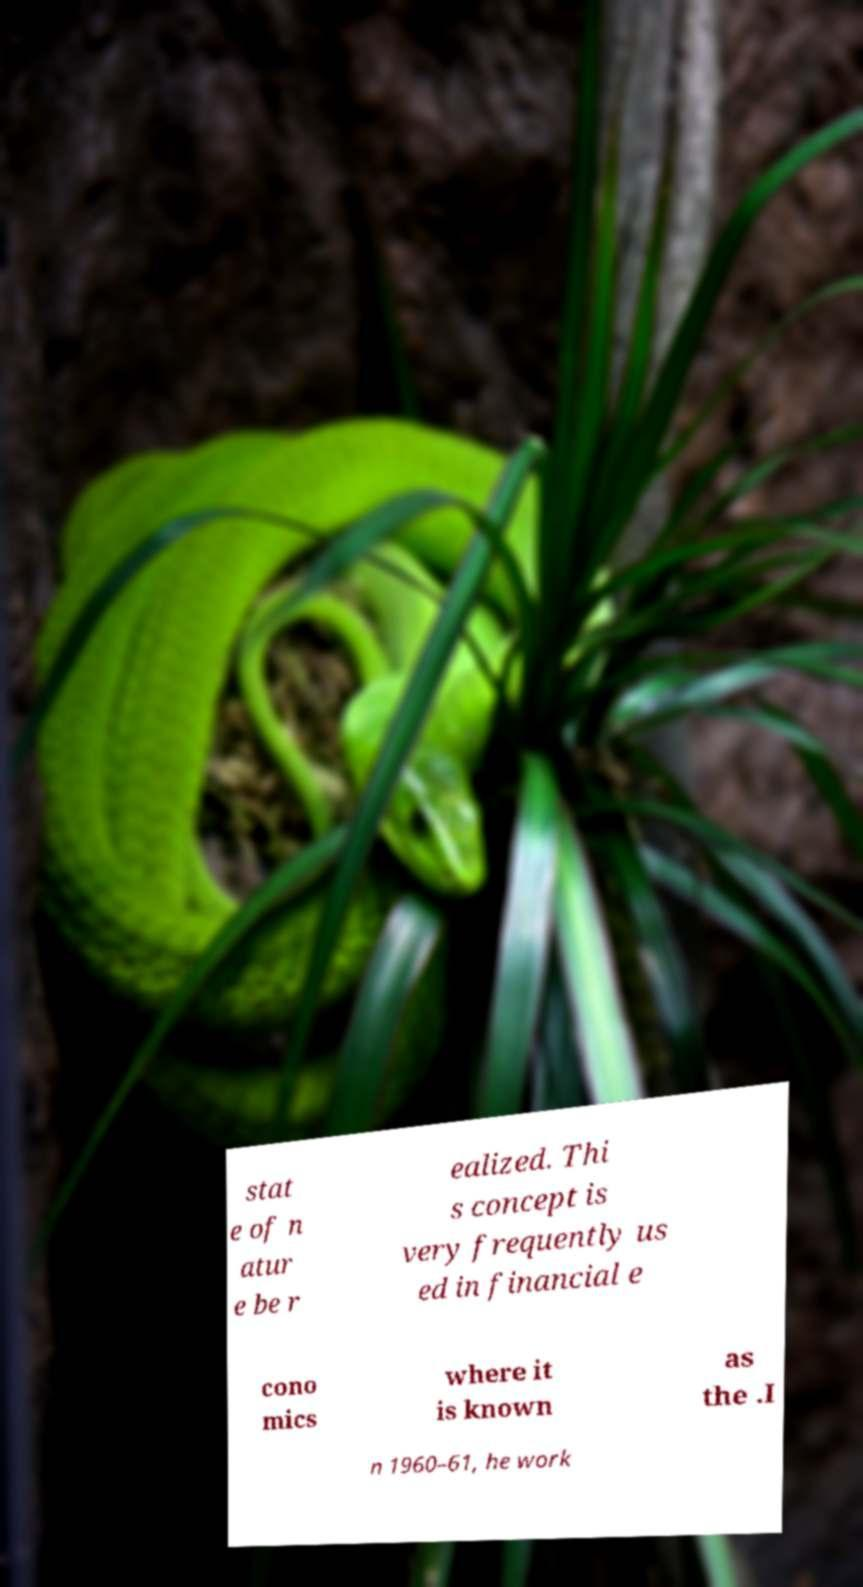Please read and relay the text visible in this image. What does it say? stat e of n atur e be r ealized. Thi s concept is very frequently us ed in financial e cono mics where it is known as the .I n 1960–61, he work 